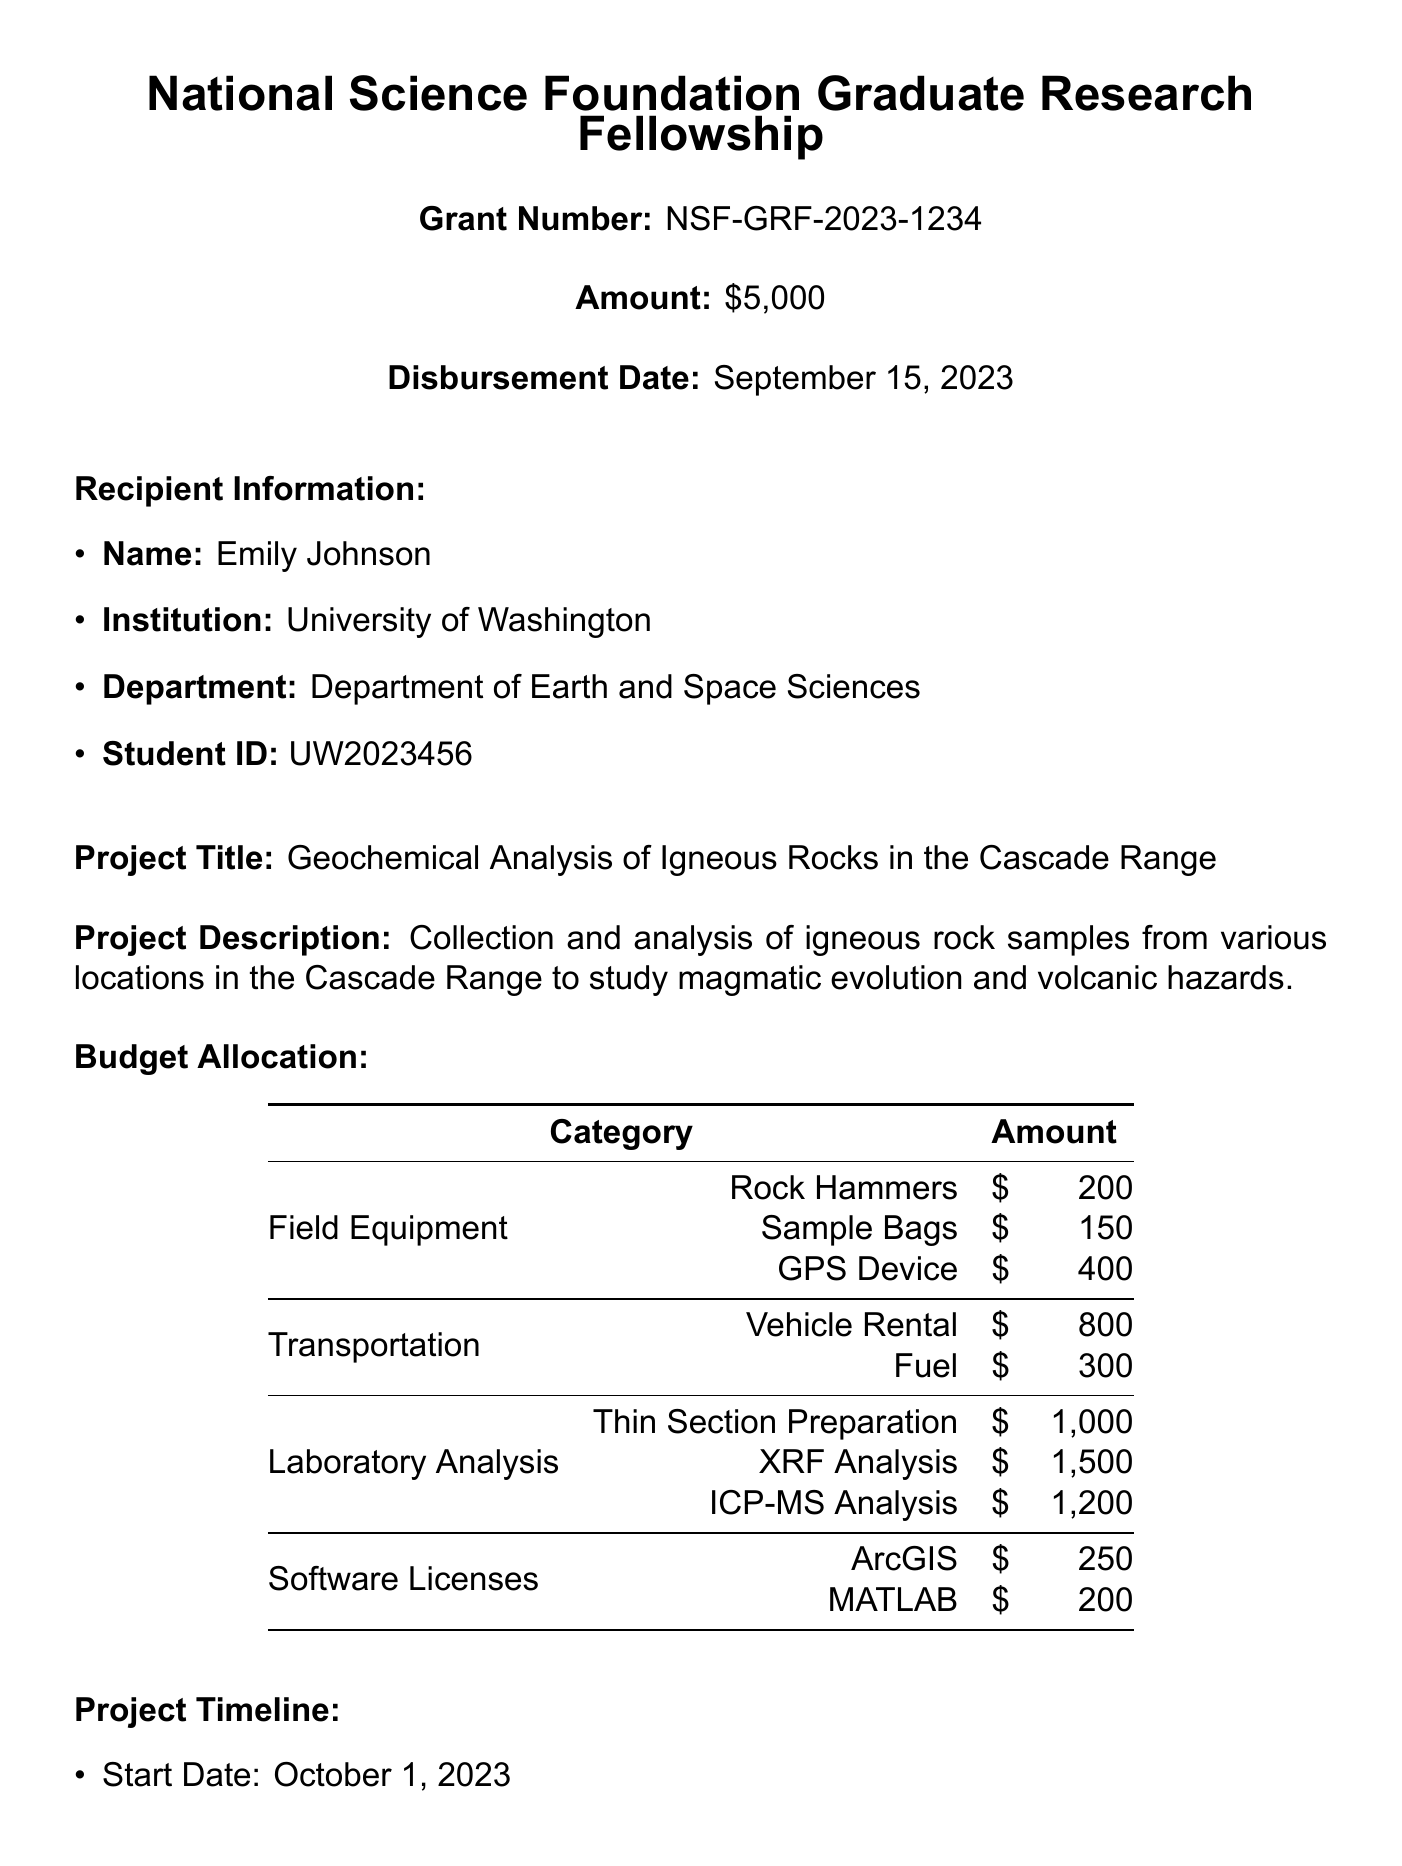What is the total grant amount? The total grant amount disbursed for the project is specified in the document as $5,000.
Answer: $5,000 What is the project title? The project title is provided in the document under the grant details section.
Answer: Geochemical Analysis of Igneous Rocks in the Cascade Range Who is the grant administrator? The document lists contact information, including the name of the grant administrator.
Answer: Dr. Sarah Thompson What is the due date for the progress report? The due date for the progress report is mentioned under the reporting requirements section.
Answer: January 31, 2024 What is the total budget allocated for laboratory analysis? The laboratory analysis section specifies amounts for different analysis types, which can be summarized to get a total.
Answer: $3,700 What is the start date of the project? The start date is specified in the project timeline section of the document.
Answer: October 1, 2023 How is the grant amount disbursed? The method of disbursement is clearly stated in the document.
Answer: Electronic Funds Transfer What is the category with the largest budget allocation? The budget allocation details show various categories, allowing comparison to identify the largest one.
Answer: Laboratory Analysis What is the student ID of the recipient? The document contains specific recipient information, including the student ID.
Answer: UW2023456 